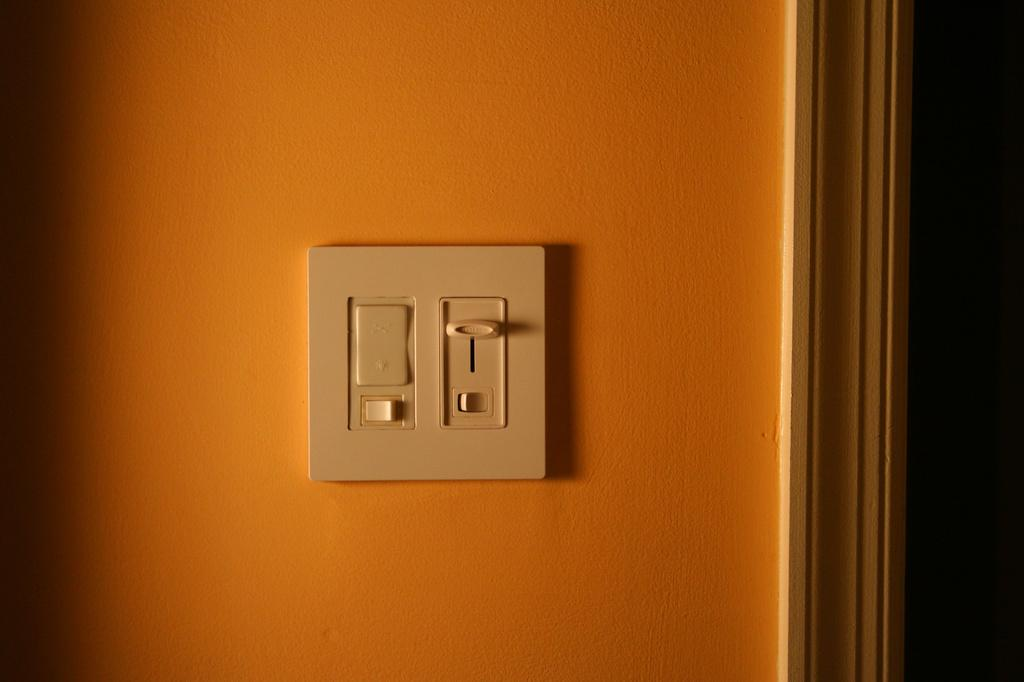What color is the wall that is visible in the image? There is an orange color wall in the image. What object can be seen on the wall in the image? There is a switch box on the wall in the image. What feature is present in the room that allows access to other areas? There is a door in the image. Where was the image taken? The image was taken in a room. How much money is hanging from the ceiling in the image? There is no money hanging from the ceiling in the image. Is there a bat flying around in the room in the image? There is no bat present in the image. 